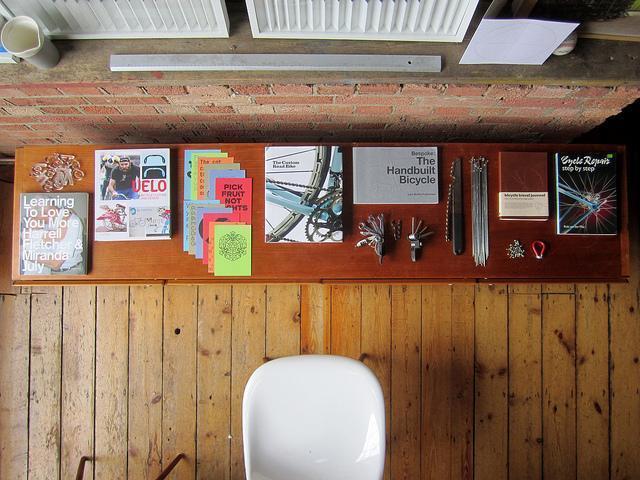How many books can you see?
Give a very brief answer. 6. 